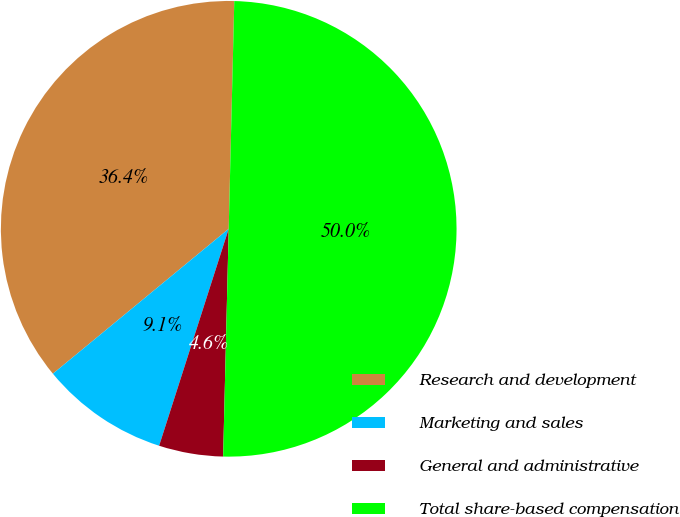<chart> <loc_0><loc_0><loc_500><loc_500><pie_chart><fcel>Research and development<fcel>Marketing and sales<fcel>General and administrative<fcel>Total share-based compensation<nl><fcel>36.36%<fcel>9.09%<fcel>4.55%<fcel>50.0%<nl></chart> 